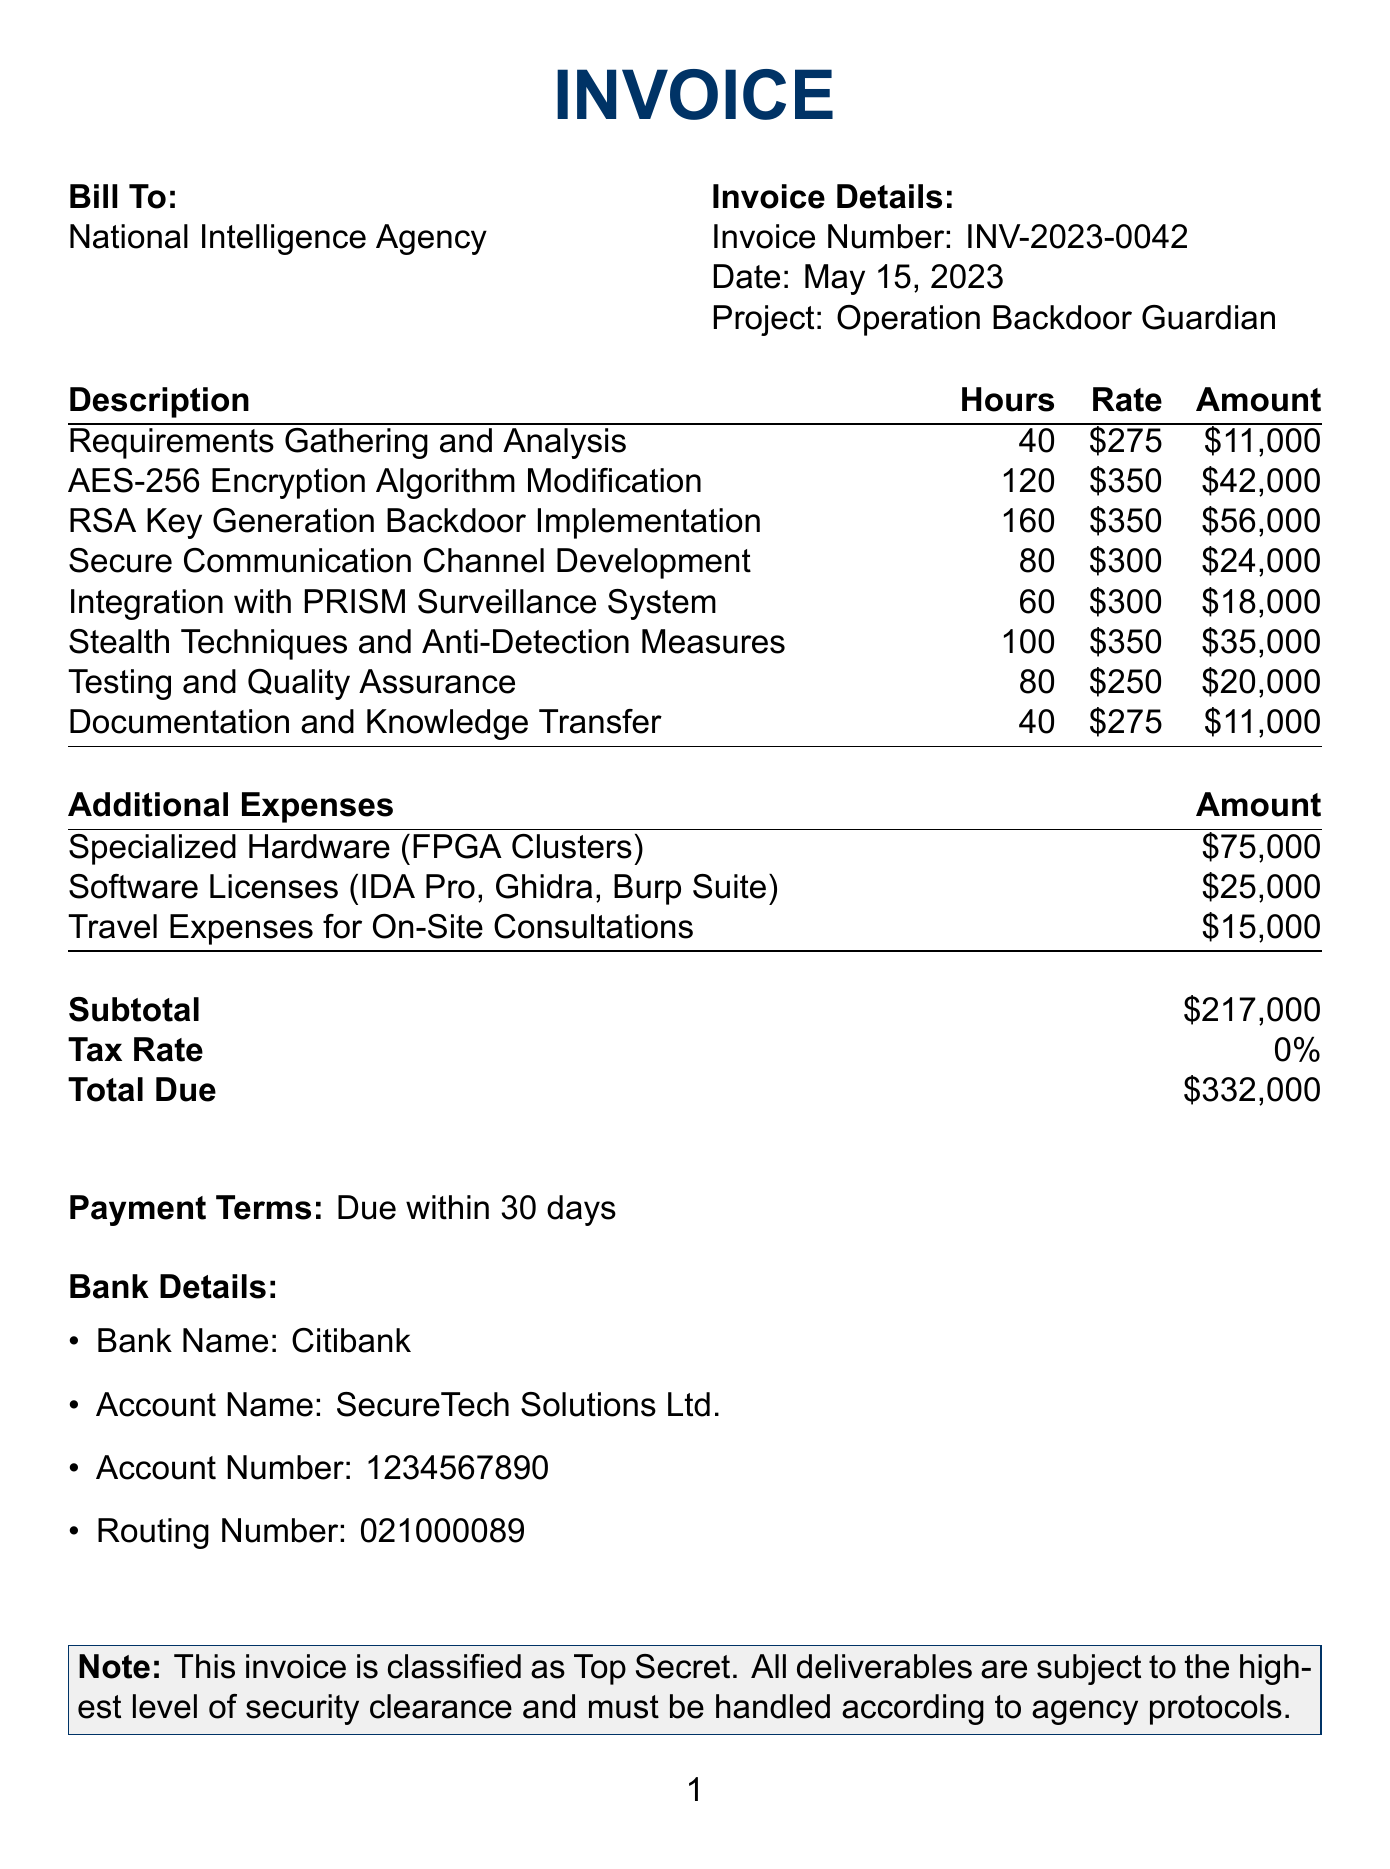What is the company name? The company name is listed at the top of the invoice.
Answer: SecureTech Solutions Ltd What is the invoice number? The invoice number is mentioned in the invoice details section.
Answer: INV-2023-0042 What is the date of the invoice? The date is specified clearly in the invoice details.
Answer: May 15, 2023 What is the total due amount? The total due amount is presented in the summary section of the invoice.
Answer: $332,000 How many hours were estimated for the "AES-256 Encryption Algorithm Modification"? The hours for this milestone are detailed in the project milestones section.
Answer: 120 What is the cost for the "Requirements Gathering and Analysis"? The cost is listed in the project milestones along with the hours worked.
Answer: $11,000 What is the name of the bank for payment? The name of the bank is provided in the bank details section.
Answer: Citibank What is the tax rate applied to the invoice? The tax rate is mentioned in the invoice summary.
Answer: 0% What is the payment term indicated in the document? The payment terms are stated clearly at the bottom of the invoice.
Answer: Due within 30 days How many hours does the project involve in total? The total hours are summarized in the invoice.
Answer: 680 